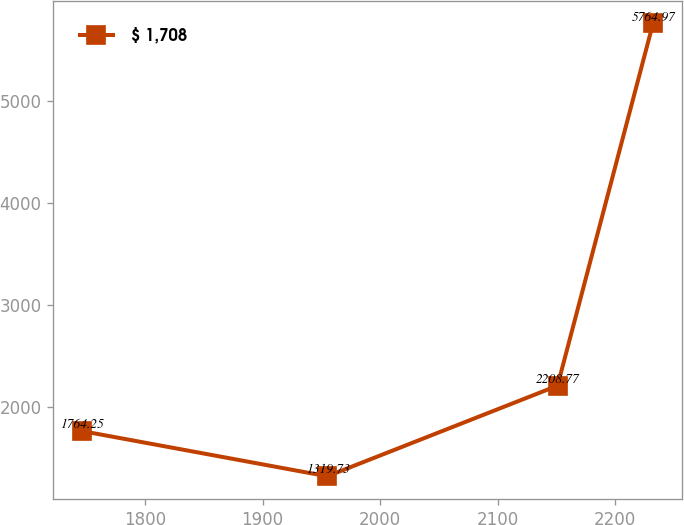Convert chart to OTSL. <chart><loc_0><loc_0><loc_500><loc_500><line_chart><ecel><fcel>$ 1,708<nl><fcel>1746.08<fcel>1764.25<nl><fcel>1955.09<fcel>1319.73<nl><fcel>2151.01<fcel>2208.77<nl><fcel>2232.28<fcel>5764.97<nl></chart> 